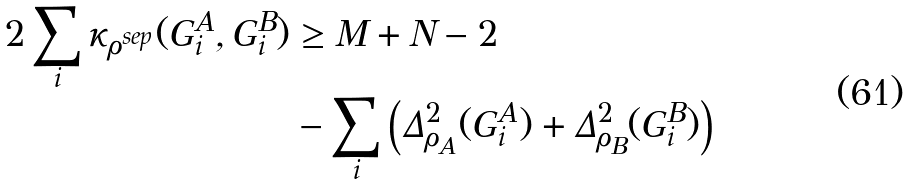<formula> <loc_0><loc_0><loc_500><loc_500>2 \sum _ { i } \kappa _ { \rho ^ { s e p } } ( G ^ { A } _ { i } , G ^ { B } _ { i } ) & \geq M + N - 2 \\ & - \sum _ { i } \left ( \Delta ^ { 2 } _ { \rho _ { A } } ( G _ { i } ^ { A } ) + \Delta ^ { 2 } _ { \rho _ { B } } ( G _ { i } ^ { B } ) \right )</formula> 